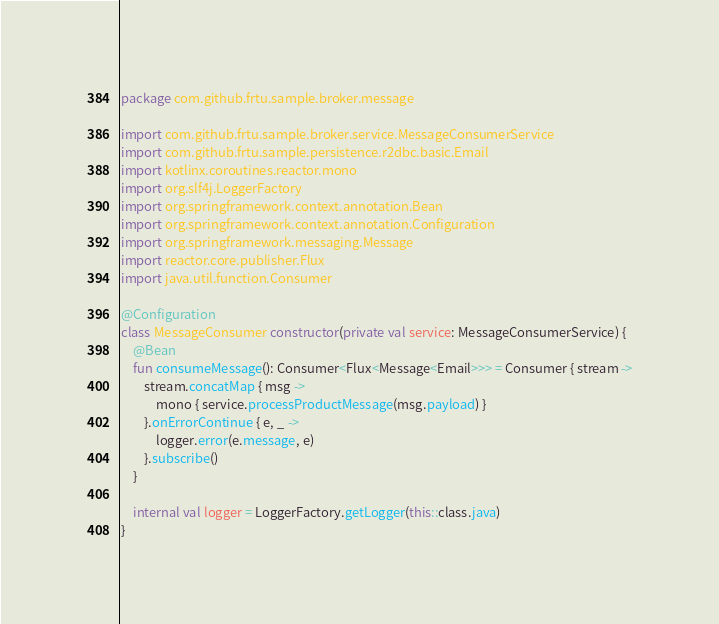<code> <loc_0><loc_0><loc_500><loc_500><_Kotlin_>package com.github.frtu.sample.broker.message

import com.github.frtu.sample.broker.service.MessageConsumerService
import com.github.frtu.sample.persistence.r2dbc.basic.Email
import kotlinx.coroutines.reactor.mono
import org.slf4j.LoggerFactory
import org.springframework.context.annotation.Bean
import org.springframework.context.annotation.Configuration
import org.springframework.messaging.Message
import reactor.core.publisher.Flux
import java.util.function.Consumer

@Configuration
class MessageConsumer constructor(private val service: MessageConsumerService) {
    @Bean
    fun consumeMessage(): Consumer<Flux<Message<Email>>> = Consumer { stream ->
        stream.concatMap { msg ->
            mono { service.processProductMessage(msg.payload) }
        }.onErrorContinue { e, _ ->
            logger.error(e.message, e)
        }.subscribe()
    }

    internal val logger = LoggerFactory.getLogger(this::class.java)
}
</code> 